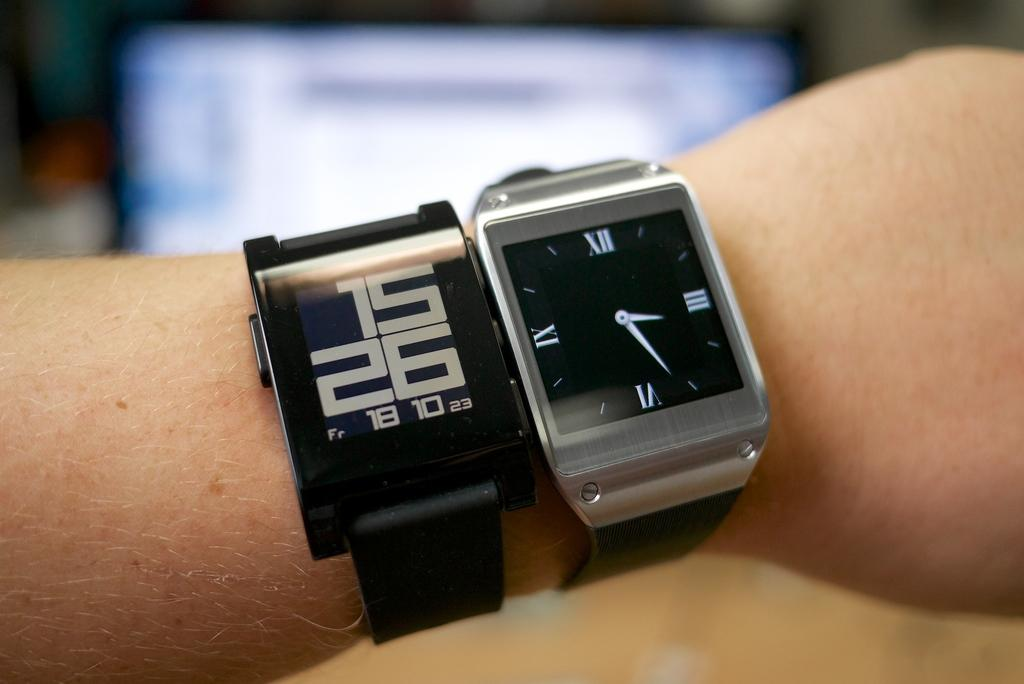Provide a one-sentence caption for the provided image. two watches, a digital and an analogue stating the time at 15.26. 